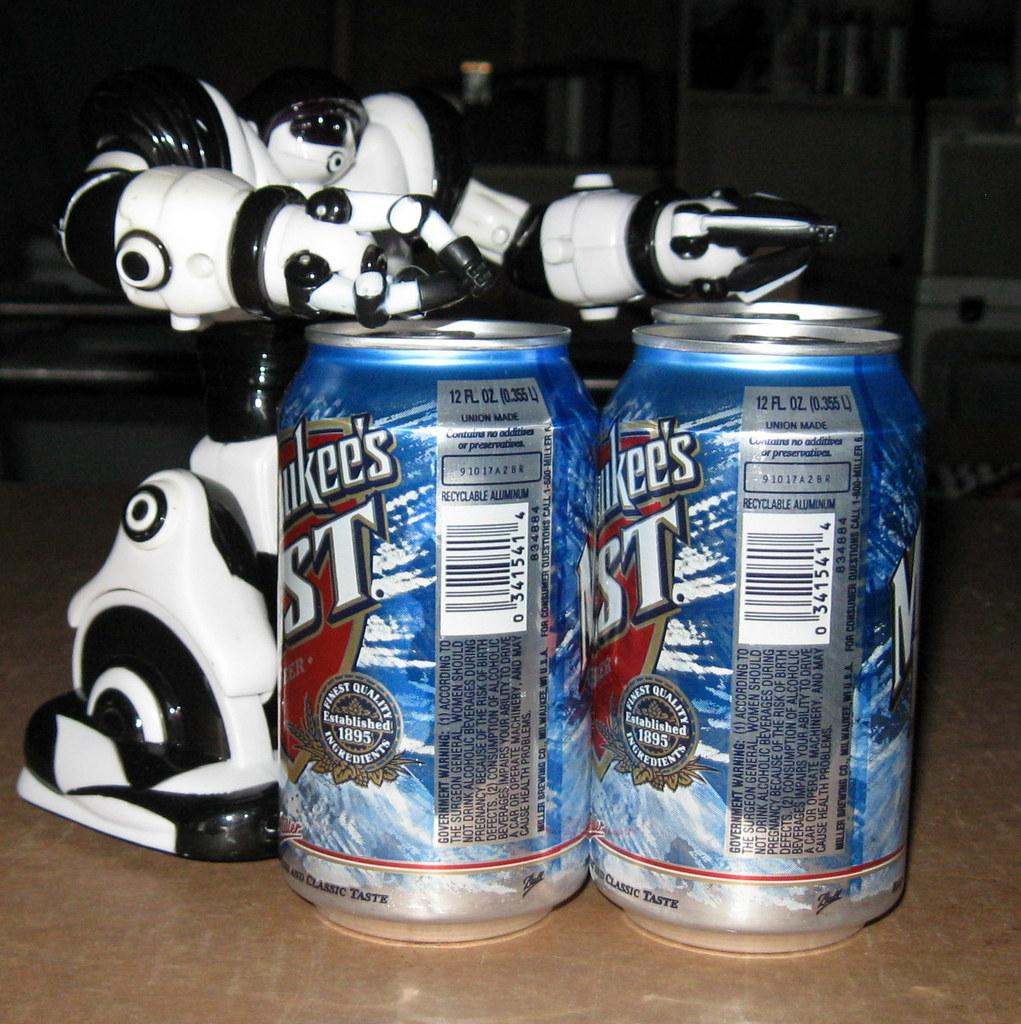<image>
Offer a succinct explanation of the picture presented. Beer cans which are both 12 fluid ounce. 